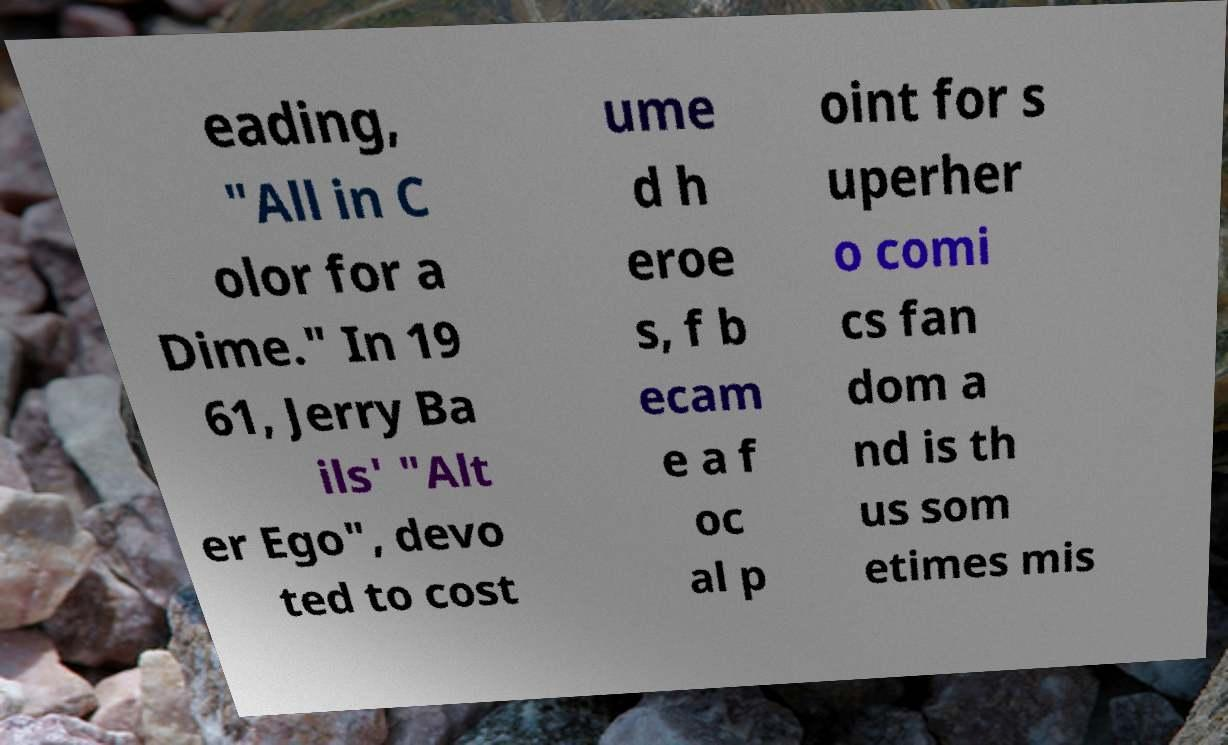I need the written content from this picture converted into text. Can you do that? eading, "All in C olor for a Dime." In 19 61, Jerry Ba ils' "Alt er Ego", devo ted to cost ume d h eroe s, f b ecam e a f oc al p oint for s uperher o comi cs fan dom a nd is th us som etimes mis 